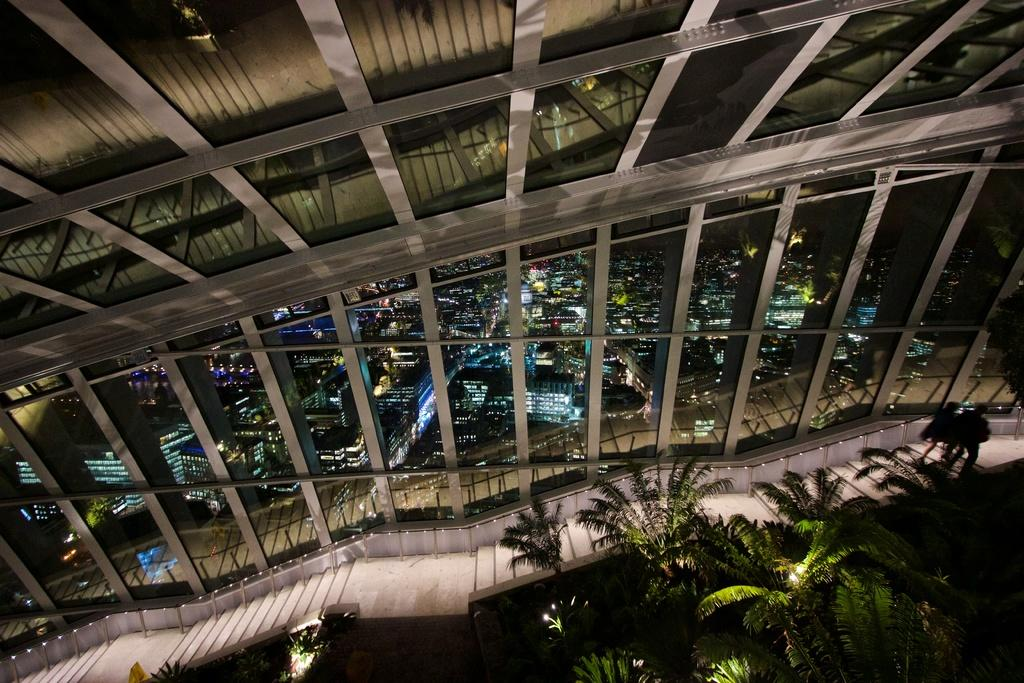What type of vegetation is in the front of the image? There are trees in the front of the image. What material is used for the walls in the image? The walls in the image are made of glass. What can be seen through the glass walls? Many buildings are visible through the glass walls. Where is the flock of birds flying in the image? There is no flock of birds present in the image. What type of amusement park can be seen in the image? There is no amusement park present in the image. 